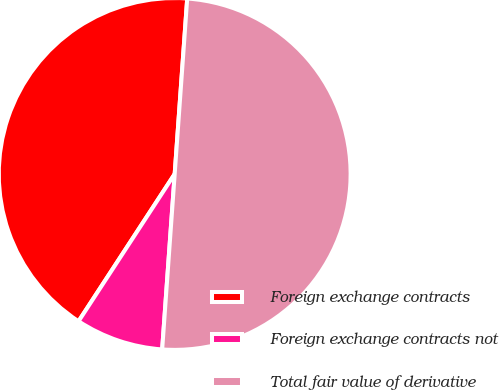<chart> <loc_0><loc_0><loc_500><loc_500><pie_chart><fcel>Foreign exchange contracts<fcel>Foreign exchange contracts not<fcel>Total fair value of derivative<nl><fcel>41.93%<fcel>8.07%<fcel>50.0%<nl></chart> 